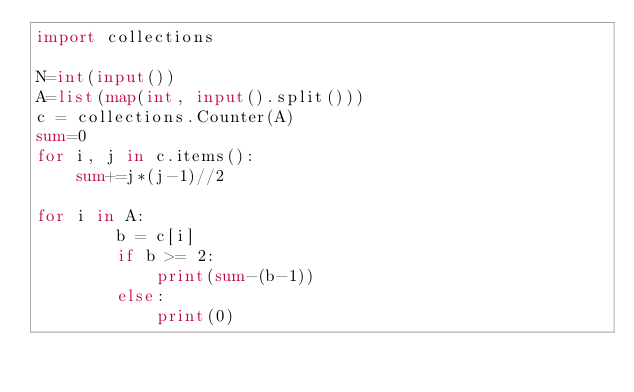<code> <loc_0><loc_0><loc_500><loc_500><_Python_>import collections

N=int(input())
A=list(map(int, input().split()))
c = collections.Counter(A)
sum=0
for i, j in c.items():
    sum+=j*(j-1)//2

for i in A:
        b = c[i]
        if b >= 2:
            print(sum-(b-1))
        else:
            print(0)</code> 